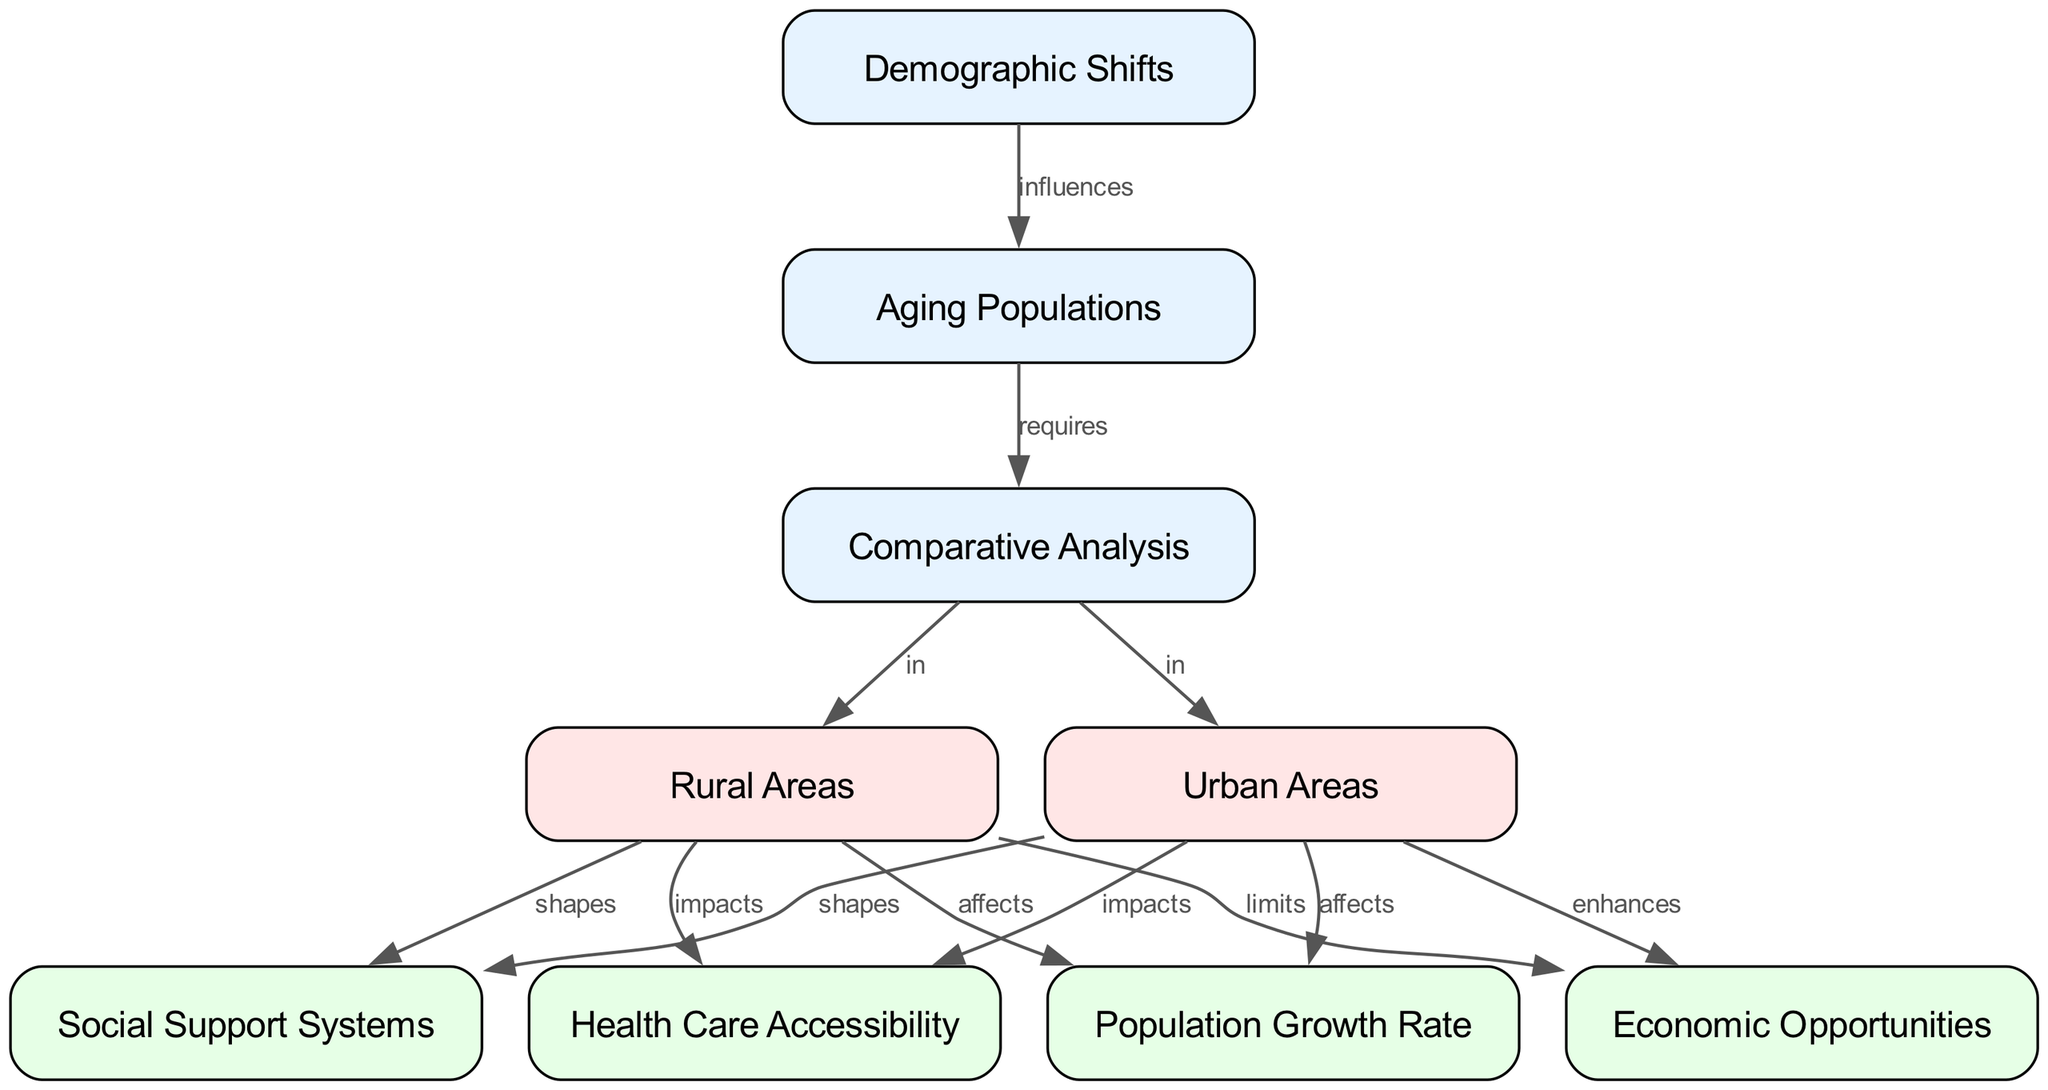What is the label of the first node? The first node has the label "Demographic Shifts." This can be found as the first entry in the nodes section of the provided data.
Answer: Demographic Shifts How many nodes are present in the diagram? The diagram contains a total of nine nodes, as seen in the nodes section of the data.
Answer: 9 What relationship does "Rural Areas" have with "Health Care Accessibility"? "Rural Areas" impacts "Health Care Accessibility," as indicated by the directed edge connecting these two nodes in the diagram.
Answer: impacts Which node is affected by the "Population Growth Rate" in "Urban Areas"? The "Population Growth Rate" is affected by "Urban Areas," as indicated by the directed edge connecting these two nodes.
Answer: Population Growth Rate What effect does "Rural Areas" have on "Economic Opportunities"? "Rural Areas" limits "Economic Opportunities," as represented by the directed edge connecting these two nodes in the diagram.
Answer: limits How does the demographic shift influence aging populations? The demographic shift influences aging populations directly, as indicated by the relationship specified in the diagram between "Demographic Shifts" and "Aging Populations."
Answer: influences What is the primary factor that shapes social support systems in both rural and urban areas? Social support systems are shaped in both areas according to the relationships illustrated between "Rural Areas" and "Social Support Systems," as well as between "Urban Areas" and "Social Support Systems."
Answer: shapes In which areas does the comparative analysis take place? The comparative analysis takes place in "Rural Areas" and "Urban Areas," as denoted by the edges connecting the comparative analysis node to these area nodes.
Answer: Rural Areas, Urban Areas How does "Urban Areas" affect the economic opportunities? "Urban Areas" enhances economic opportunities, as indicated by the edge connecting "Urban Areas" to "Economic Opportunities."
Answer: enhances 